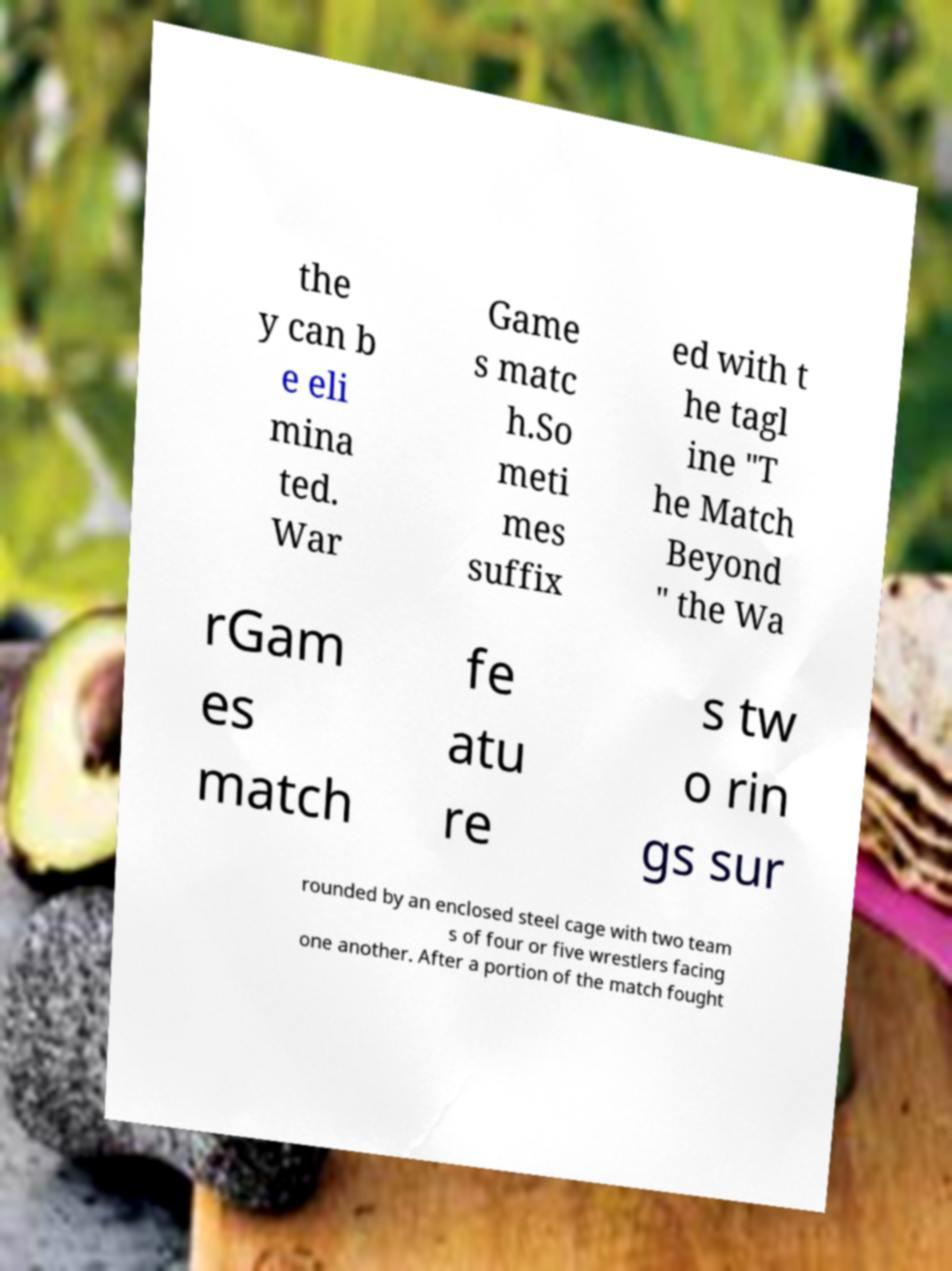Could you assist in decoding the text presented in this image and type it out clearly? the y can b e eli mina ted. War Game s matc h.So meti mes suffix ed with t he tagl ine "T he Match Beyond " the Wa rGam es match fe atu re s tw o rin gs sur rounded by an enclosed steel cage with two team s of four or five wrestlers facing one another. After a portion of the match fought 